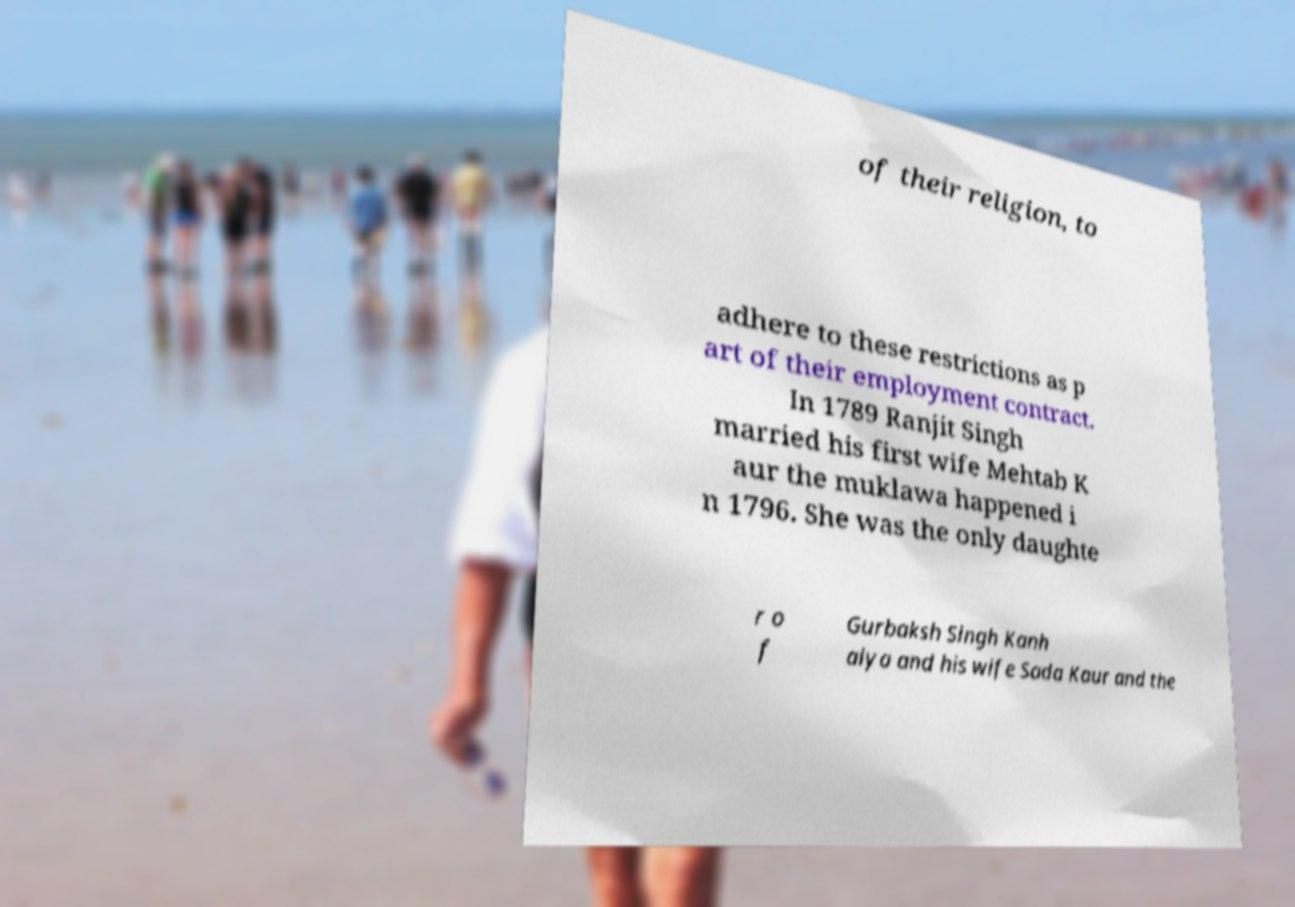Please read and relay the text visible in this image. What does it say? of their religion, to adhere to these restrictions as p art of their employment contract. In 1789 Ranjit Singh married his first wife Mehtab K aur the muklawa happened i n 1796. She was the only daughte r o f Gurbaksh Singh Kanh aiya and his wife Sada Kaur and the 